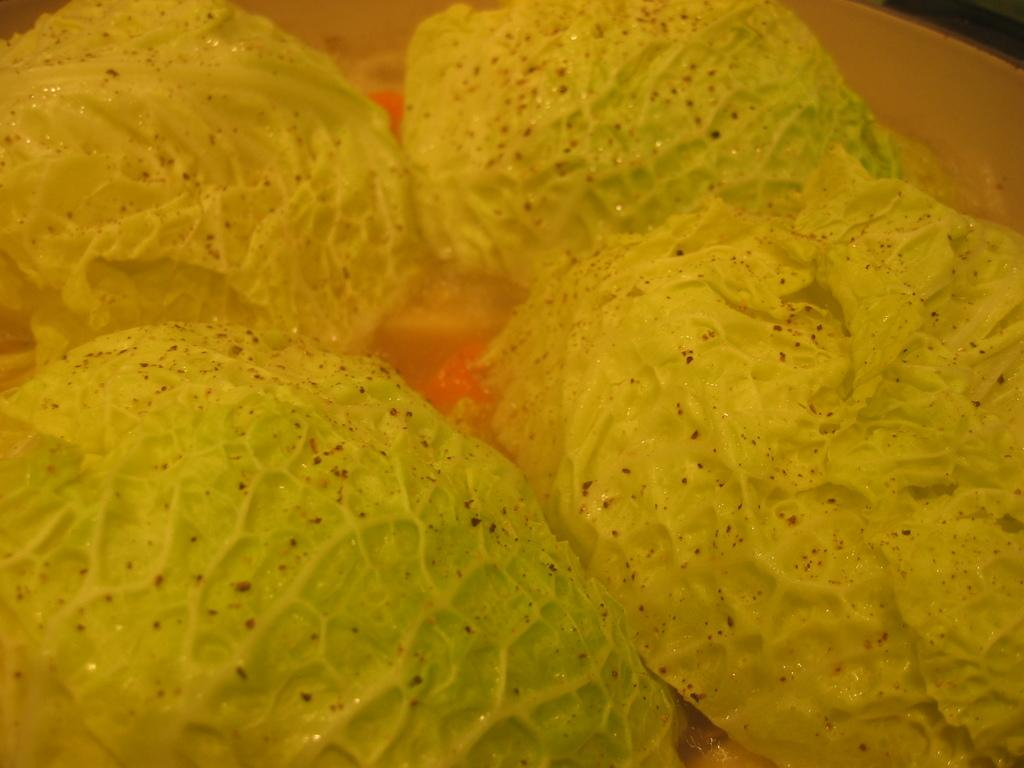What is the main subject of the image? There is a food item in the image. Where is the food item located? The food item is in a white object. What can be seen in the foreground of the image? The white object is in the foreground of the image. What type of hydrant is visible in the image? There is no hydrant present in the image. How many copies of the food item can be seen in the image? There is only one food item visible in the image, so there are no copies. 